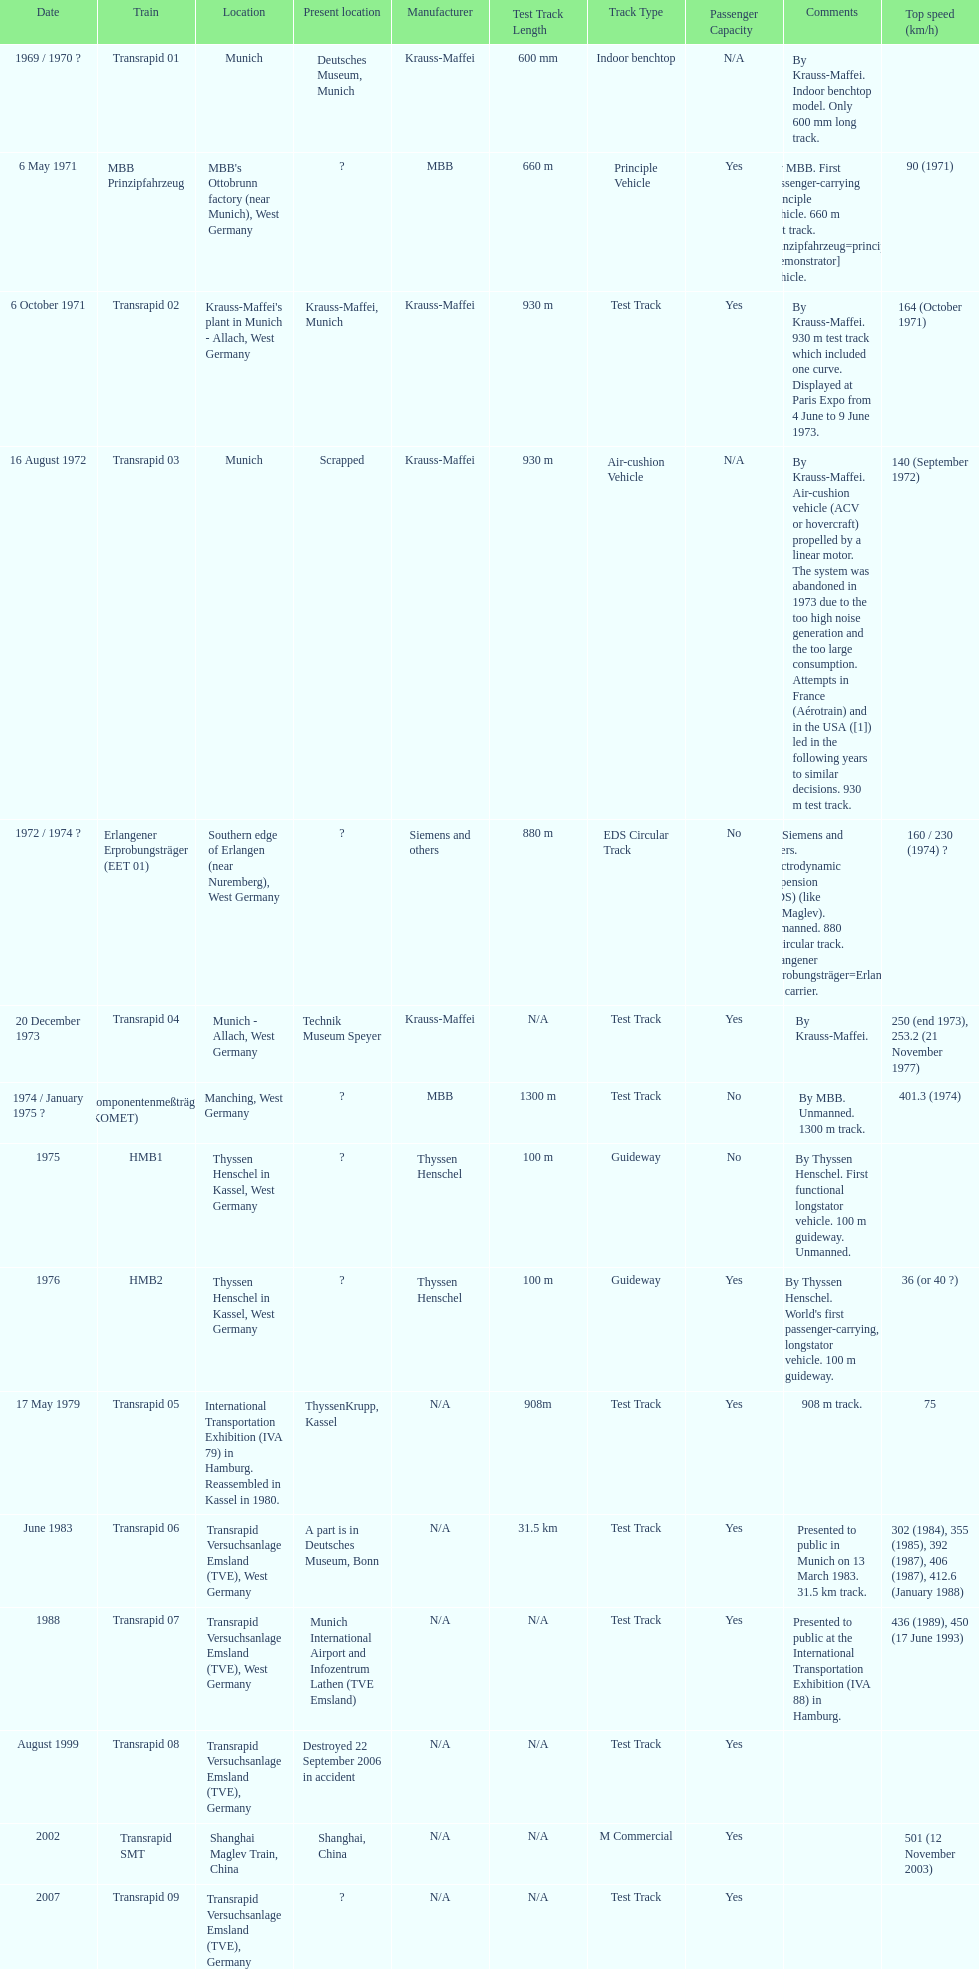Tell me the number of versions that are scrapped. 1. 